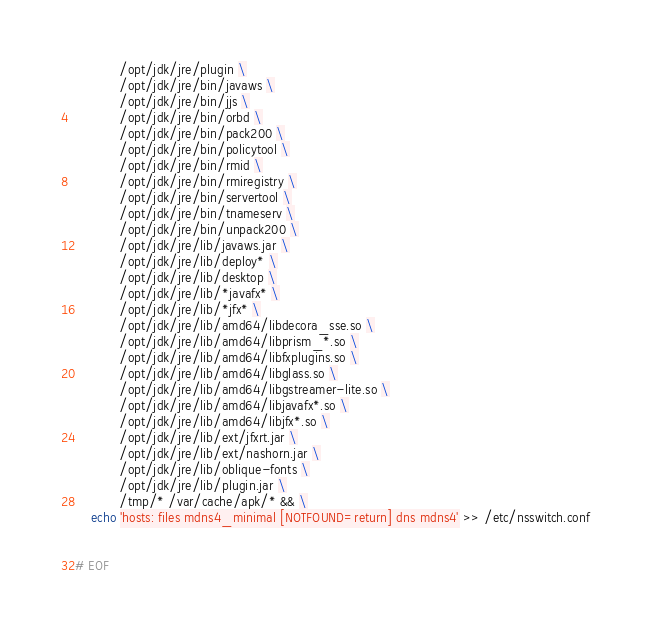<code> <loc_0><loc_0><loc_500><loc_500><_Dockerfile_>           /opt/jdk/jre/plugin \
           /opt/jdk/jre/bin/javaws \
           /opt/jdk/jre/bin/jjs \
           /opt/jdk/jre/bin/orbd \
           /opt/jdk/jre/bin/pack200 \
           /opt/jdk/jre/bin/policytool \
           /opt/jdk/jre/bin/rmid \
           /opt/jdk/jre/bin/rmiregistry \
           /opt/jdk/jre/bin/servertool \
           /opt/jdk/jre/bin/tnameserv \
           /opt/jdk/jre/bin/unpack200 \
           /opt/jdk/jre/lib/javaws.jar \
           /opt/jdk/jre/lib/deploy* \
           /opt/jdk/jre/lib/desktop \
           /opt/jdk/jre/lib/*javafx* \
           /opt/jdk/jre/lib/*jfx* \
           /opt/jdk/jre/lib/amd64/libdecora_sse.so \
           /opt/jdk/jre/lib/amd64/libprism_*.so \
           /opt/jdk/jre/lib/amd64/libfxplugins.so \
           /opt/jdk/jre/lib/amd64/libglass.so \
           /opt/jdk/jre/lib/amd64/libgstreamer-lite.so \
           /opt/jdk/jre/lib/amd64/libjavafx*.so \
           /opt/jdk/jre/lib/amd64/libjfx*.so \
           /opt/jdk/jre/lib/ext/jfxrt.jar \
           /opt/jdk/jre/lib/ext/nashorn.jar \
           /opt/jdk/jre/lib/oblique-fonts \
           /opt/jdk/jre/lib/plugin.jar \
           /tmp/* /var/cache/apk/* && \
    echo 'hosts: files mdns4_minimal [NOTFOUND=return] dns mdns4' >> /etc/nsswitch.conf


# EOF
</code> 